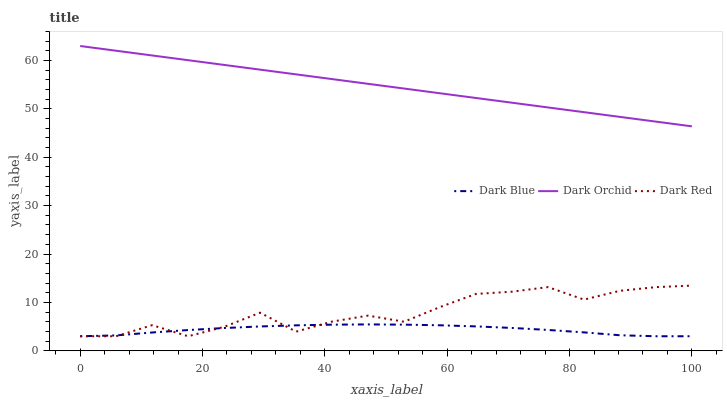Does Dark Blue have the minimum area under the curve?
Answer yes or no. Yes. Does Dark Orchid have the maximum area under the curve?
Answer yes or no. Yes. Does Dark Red have the minimum area under the curve?
Answer yes or no. No. Does Dark Red have the maximum area under the curve?
Answer yes or no. No. Is Dark Orchid the smoothest?
Answer yes or no. Yes. Is Dark Red the roughest?
Answer yes or no. Yes. Is Dark Red the smoothest?
Answer yes or no. No. Is Dark Orchid the roughest?
Answer yes or no. No. Does Dark Blue have the lowest value?
Answer yes or no. Yes. Does Dark Orchid have the lowest value?
Answer yes or no. No. Does Dark Orchid have the highest value?
Answer yes or no. Yes. Does Dark Red have the highest value?
Answer yes or no. No. Is Dark Blue less than Dark Orchid?
Answer yes or no. Yes. Is Dark Orchid greater than Dark Blue?
Answer yes or no. Yes. Does Dark Blue intersect Dark Red?
Answer yes or no. Yes. Is Dark Blue less than Dark Red?
Answer yes or no. No. Is Dark Blue greater than Dark Red?
Answer yes or no. No. Does Dark Blue intersect Dark Orchid?
Answer yes or no. No. 